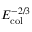Convert formula to latex. <formula><loc_0><loc_0><loc_500><loc_500>E _ { c o l } ^ { - 2 / 3 }</formula> 